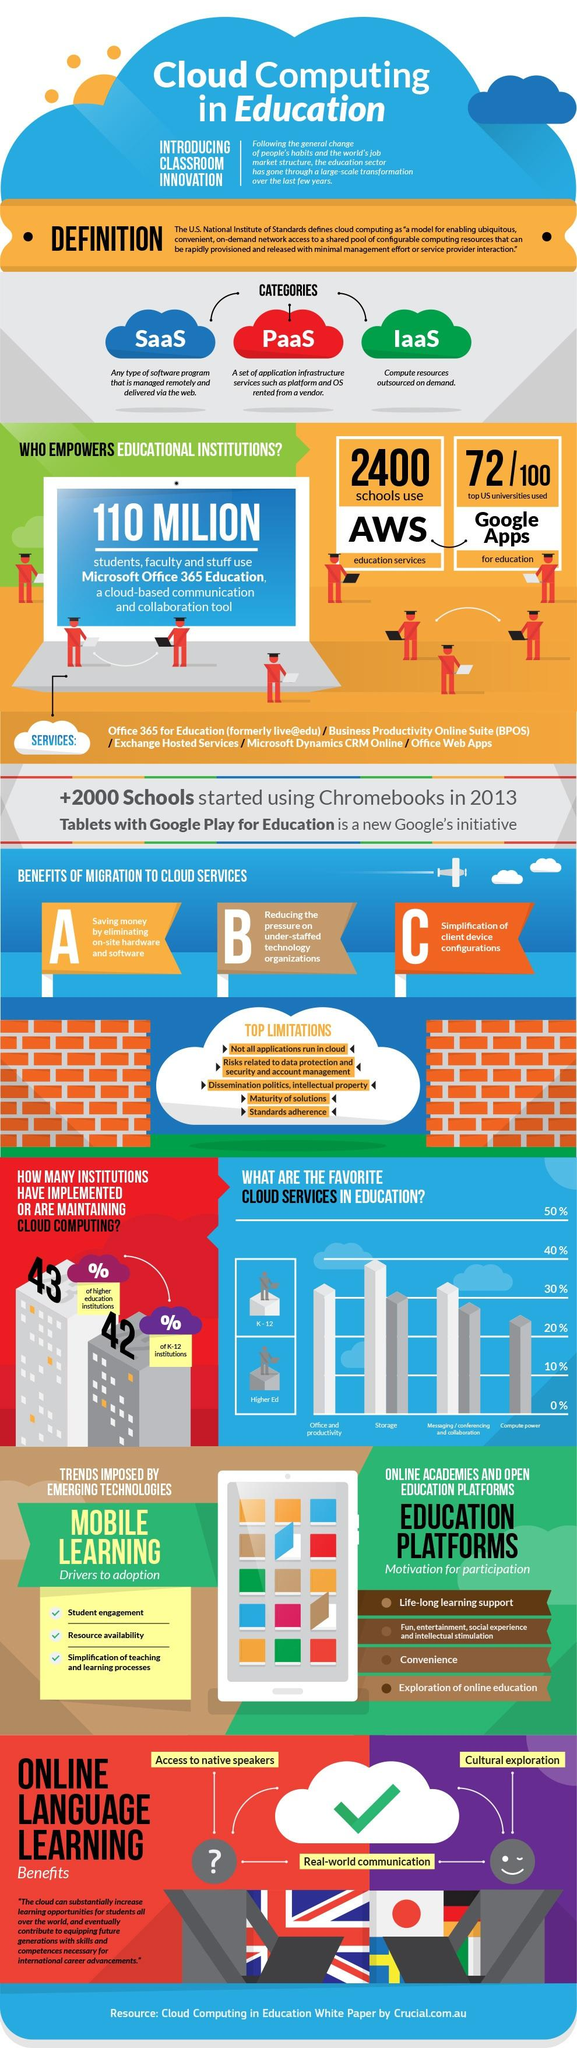Highlight a few significant elements in this photo. AWS education services are used by approximately 2,400 schools. Microsoft Office 365 is used by 110 million students, faculty, and staff worldwide. Only 28 of the top 100 universities in the United States do not use Google Apps for Education. 